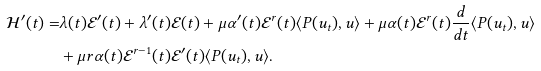Convert formula to latex. <formula><loc_0><loc_0><loc_500><loc_500>\mathcal { H } ^ { \prime } ( t ) = & \lambda ( t ) \mathcal { E } ^ { \prime } ( t ) + \lambda ^ { \prime } ( t ) \mathcal { E } ( t ) + \mu \alpha ^ { \prime } ( t ) \mathcal { E } ^ { r } ( t ) \langle P ( u _ { t } ) , u \rangle + \mu \alpha ( t ) \mathcal { E } ^ { r } ( t ) \frac { d } { d t } \langle P ( u _ { t } ) , u \rangle \\ & + \mu r \alpha ( t ) \mathcal { E } ^ { r - 1 } ( t ) \mathcal { E } ^ { \prime } ( t ) \langle P ( u _ { t } ) , u \rangle .</formula> 